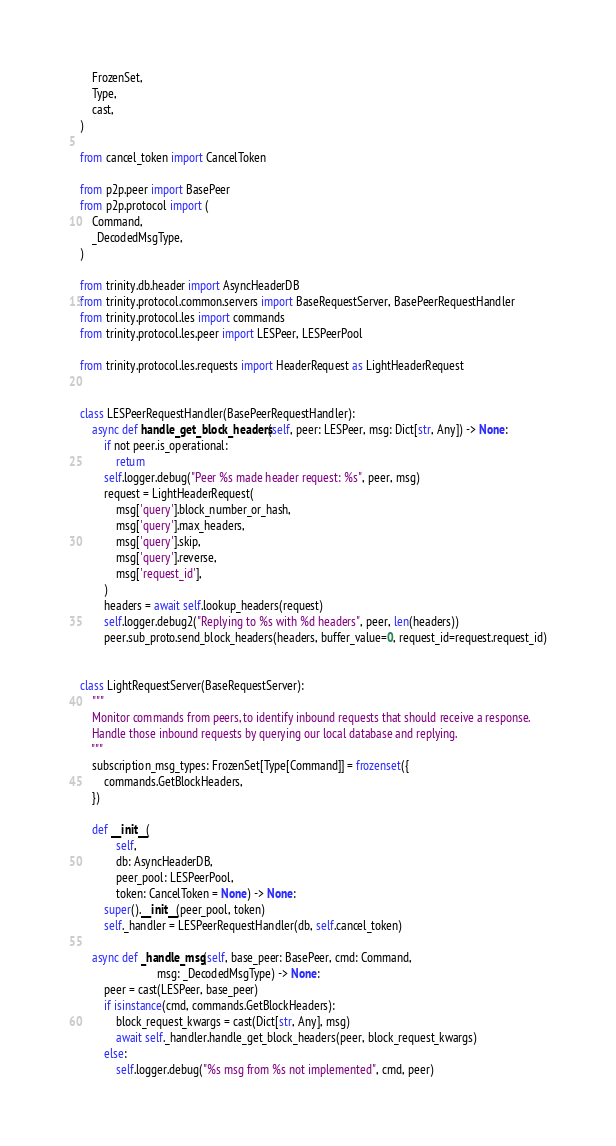<code> <loc_0><loc_0><loc_500><loc_500><_Python_>    FrozenSet,
    Type,
    cast,
)

from cancel_token import CancelToken

from p2p.peer import BasePeer
from p2p.protocol import (
    Command,
    _DecodedMsgType,
)

from trinity.db.header import AsyncHeaderDB
from trinity.protocol.common.servers import BaseRequestServer, BasePeerRequestHandler
from trinity.protocol.les import commands
from trinity.protocol.les.peer import LESPeer, LESPeerPool

from trinity.protocol.les.requests import HeaderRequest as LightHeaderRequest


class LESPeerRequestHandler(BasePeerRequestHandler):
    async def handle_get_block_headers(self, peer: LESPeer, msg: Dict[str, Any]) -> None:
        if not peer.is_operational:
            return
        self.logger.debug("Peer %s made header request: %s", peer, msg)
        request = LightHeaderRequest(
            msg['query'].block_number_or_hash,
            msg['query'].max_headers,
            msg['query'].skip,
            msg['query'].reverse,
            msg['request_id'],
        )
        headers = await self.lookup_headers(request)
        self.logger.debug2("Replying to %s with %d headers", peer, len(headers))
        peer.sub_proto.send_block_headers(headers, buffer_value=0, request_id=request.request_id)


class LightRequestServer(BaseRequestServer):
    """
    Monitor commands from peers, to identify inbound requests that should receive a response.
    Handle those inbound requests by querying our local database and replying.
    """
    subscription_msg_types: FrozenSet[Type[Command]] = frozenset({
        commands.GetBlockHeaders,
    })

    def __init__(
            self,
            db: AsyncHeaderDB,
            peer_pool: LESPeerPool,
            token: CancelToken = None) -> None:
        super().__init__(peer_pool, token)
        self._handler = LESPeerRequestHandler(db, self.cancel_token)

    async def _handle_msg(self, base_peer: BasePeer, cmd: Command,
                          msg: _DecodedMsgType) -> None:
        peer = cast(LESPeer, base_peer)
        if isinstance(cmd, commands.GetBlockHeaders):
            block_request_kwargs = cast(Dict[str, Any], msg)
            await self._handler.handle_get_block_headers(peer, block_request_kwargs)
        else:
            self.logger.debug("%s msg from %s not implemented", cmd, peer)
</code> 